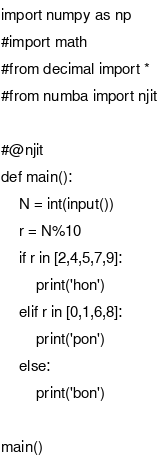<code> <loc_0><loc_0><loc_500><loc_500><_Python_>import numpy as np
#import math
#from decimal import *
#from numba import njit

#@njit
def main():
    N = int(input())
    r = N%10
    if r in [2,4,5,7,9]:
        print('hon')
    elif r in [0,1,6,8]:
        print('pon')
    else:
        print('bon')

main()
</code> 